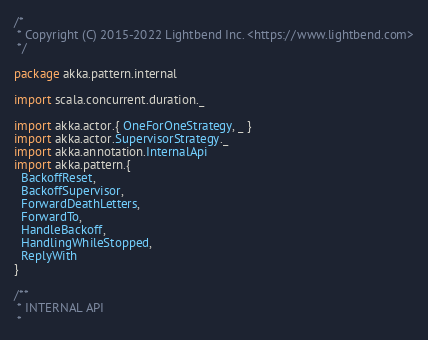Convert code to text. <code><loc_0><loc_0><loc_500><loc_500><_Scala_>/*
 * Copyright (C) 2015-2022 Lightbend Inc. <https://www.lightbend.com>
 */

package akka.pattern.internal

import scala.concurrent.duration._

import akka.actor.{ OneForOneStrategy, _ }
import akka.actor.SupervisorStrategy._
import akka.annotation.InternalApi
import akka.pattern.{
  BackoffReset,
  BackoffSupervisor,
  ForwardDeathLetters,
  ForwardTo,
  HandleBackoff,
  HandlingWhileStopped,
  ReplyWith
}

/**
 * INTERNAL API
 *</code> 